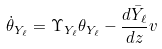<formula> <loc_0><loc_0><loc_500><loc_500>\dot { \theta } _ { Y _ { \ell } } = \Upsilon _ { Y _ { \ell } } \theta _ { Y _ { \ell } } - \frac { d \bar { Y } _ { \ell } } { d z } v</formula> 